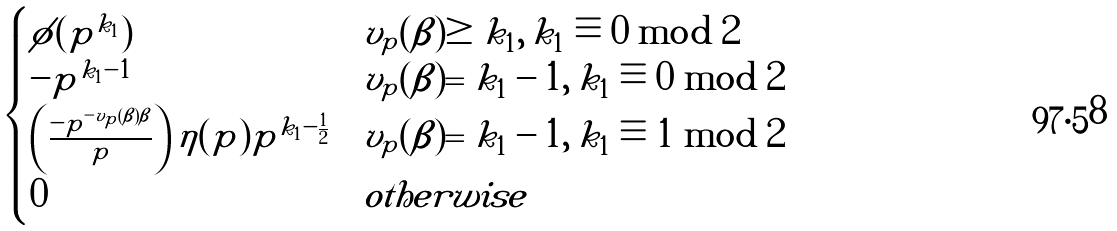<formula> <loc_0><loc_0><loc_500><loc_500>\begin{cases} \phi ( p ^ { k _ { 1 } } ) & v _ { p } ( \beta ) \geq k _ { 1 } , \, k _ { 1 } \equiv 0 \bmod 2 \\ - p ^ { k _ { 1 } - 1 } & v _ { p } ( \beta ) = k _ { 1 } - 1 , \, k _ { 1 } \equiv 0 \bmod 2 \\ \left ( \frac { - p ^ { - v _ { p } ( \beta ) \beta } } { p } \right ) \eta ( p ) p ^ { k _ { 1 } - \frac { 1 } { 2 } } & v _ { p } ( \beta ) = k _ { 1 } - 1 , \, k _ { 1 } \equiv 1 \bmod 2 \\ 0 & o t h e r w i s e \end{cases}</formula> 